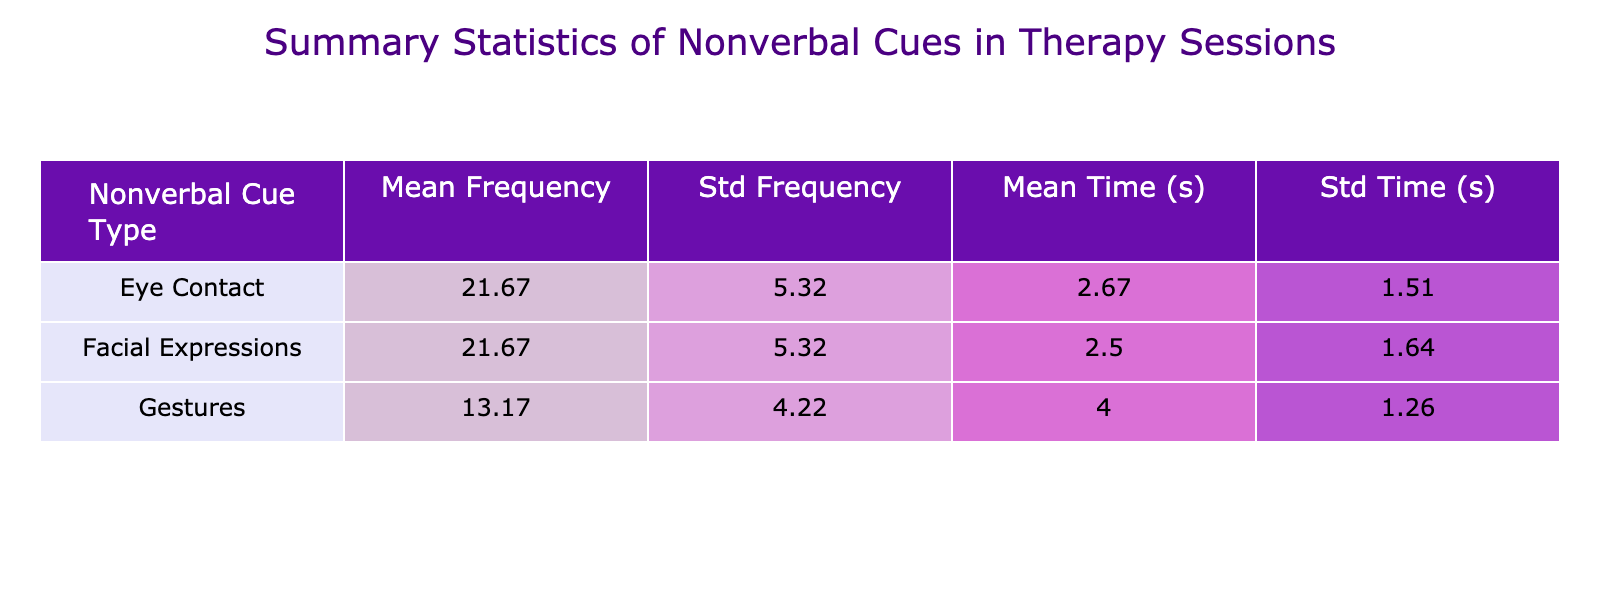What is the mean frequency of responses for Gestures? Looking at the table, I find the frequencies for Gestures across the sessions: 15, 10, 12, 8, 20, and 14. To calculate the mean, I sum these values: 15 + 10 + 12 + 8 + 20 + 14 = 79. There are 6 values, so the mean is 79 divided by 6, which equals approximately 13.17.
Answer: 13.17 Which nonverbal cue has the highest mean frequency of response? The table shows the mean frequencies of responses for each nonverbal cue: Eye Contact (20.00), Gestures (13.17), and Facial Expressions (18.33). Among these, Eye Contact has the highest mean frequency with 20.00.
Answer: Eye Contact Is the mean time to response for Facial Expressions longer than for Eye Contact? The mean time to response for Facial Expressions is 2.33 seconds and for Eye Contact is 2.00 seconds, according to the table. Since 2.33 is greater than 2.00, the answer is yes, Facial Expressions have a longer mean time to response.
Answer: Yes What is the standard deviation in the frequency of responses for Eye Contact? According to the table, the standard deviation for the frequency of Eye Contact responses is shown as 5.93. This is the measure of variation in the frequency responses for Eye Contact.
Answer: 5.93 Which communication partner had the highest total frequency of response across all nonverbal cues? I need to sum the frequencies for each communication partner. For Dr. Smith: 20 + 15 + 25 = 60; Ms. Johnson: 18 + 10 + 22 = 50; Mr. Lee: 30 + 12 + 20 = 62; Dr. Patel: 25 + 8 + 30 = 63; Ms. Taylor: 15 + 20 + 18 = 53; Mr. Brown: 22 + 14 + 15 = 51. Mr. Lee has the highest total frequency of response with 62.
Answer: Mr. Lee 